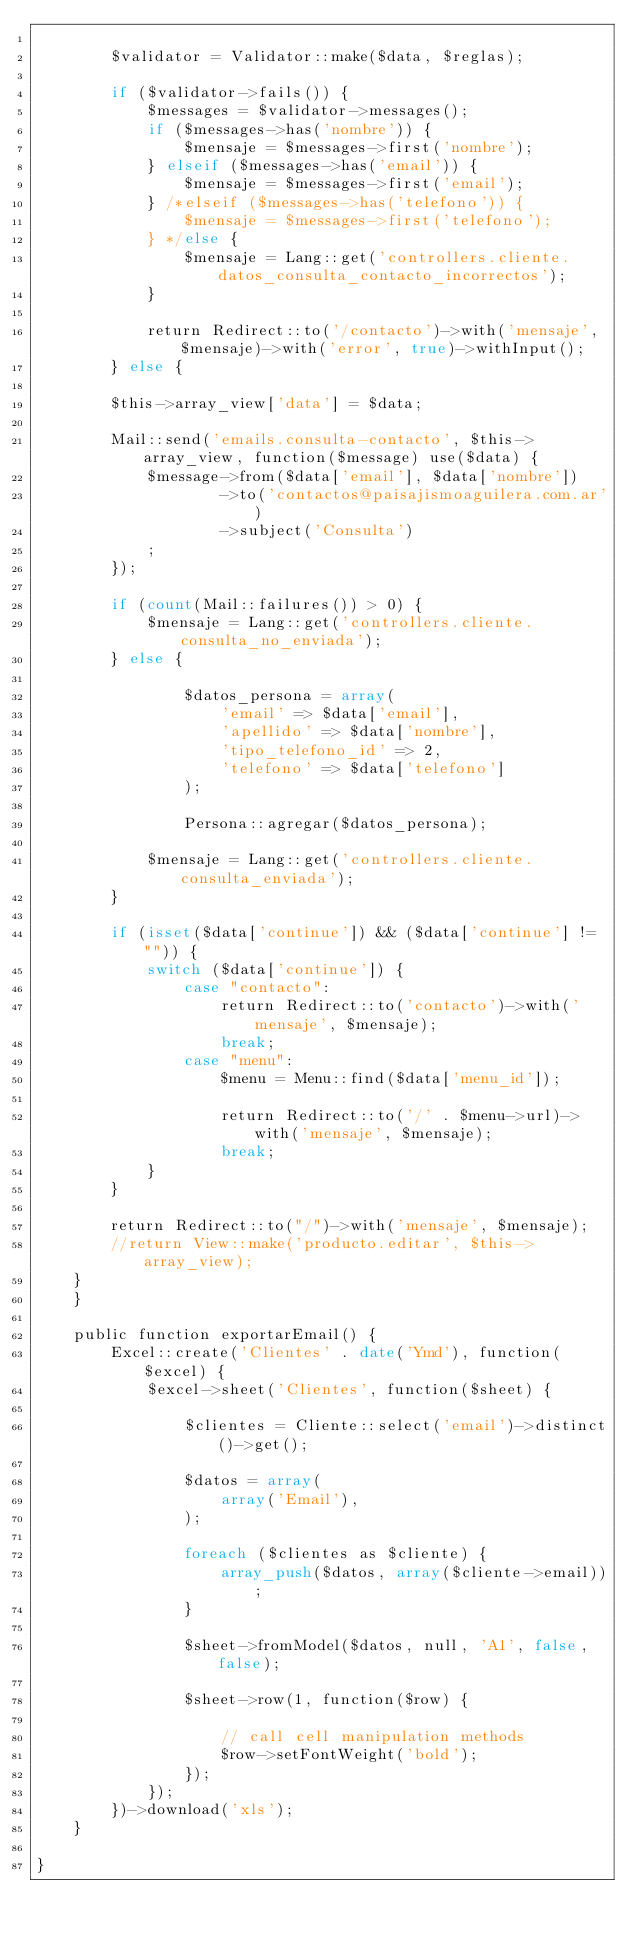<code> <loc_0><loc_0><loc_500><loc_500><_PHP_>
        $validator = Validator::make($data, $reglas);

        if ($validator->fails()) {
            $messages = $validator->messages();
            if ($messages->has('nombre')) {
                $mensaje = $messages->first('nombre');
            } elseif ($messages->has('email')) {
                $mensaje = $messages->first('email');
            } /*elseif ($messages->has('telefono')) {
                $mensaje = $messages->first('telefono');
            } */else {
                $mensaje = Lang::get('controllers.cliente.datos_consulta_contacto_incorrectos');
            }

            return Redirect::to('/contacto')->with('mensaje', $mensaje)->with('error', true)->withInput();
        } else {

        $this->array_view['data'] = $data;

        Mail::send('emails.consulta-contacto', $this->array_view, function($message) use($data) {
            $message->from($data['email'], $data['nombre'])
                    ->to('contactos@paisajismoaguilera.com.ar')
                    ->subject('Consulta')
            ;
        });

        if (count(Mail::failures()) > 0) {
            $mensaje = Lang::get('controllers.cliente.consulta_no_enviada');
        } else {

                $datos_persona = array(
                    'email' => $data['email'],
                    'apellido' => $data['nombre'],
                    'tipo_telefono_id' => 2,
                    'telefono' => $data['telefono']
                );

                Persona::agregar($datos_persona);

            $mensaje = Lang::get('controllers.cliente.consulta_enviada');
        }

        if (isset($data['continue']) && ($data['continue'] != "")) {
            switch ($data['continue']) {
                case "contacto":
                    return Redirect::to('contacto')->with('mensaje', $mensaje);
                    break;
                case "menu":
                    $menu = Menu::find($data['menu_id']);

                    return Redirect::to('/' . $menu->url)->with('mensaje', $mensaje);
                    break;
            }
        }

        return Redirect::to("/")->with('mensaje', $mensaje);
        //return View::make('producto.editar', $this->array_view);
    }
    }

    public function exportarEmail() {
        Excel::create('Clientes' . date('Ymd'), function($excel) {
            $excel->sheet('Clientes', function($sheet) {

                $clientes = Cliente::select('email')->distinct()->get();

                $datos = array(
                    array('Email'),
                );

                foreach ($clientes as $cliente) {
                    array_push($datos, array($cliente->email));
                }

                $sheet->fromModel($datos, null, 'A1', false, false);

                $sheet->row(1, function($row) {

                    // call cell manipulation methods
                    $row->setFontWeight('bold');
                });
            });
        })->download('xls');
    }

}
</code> 